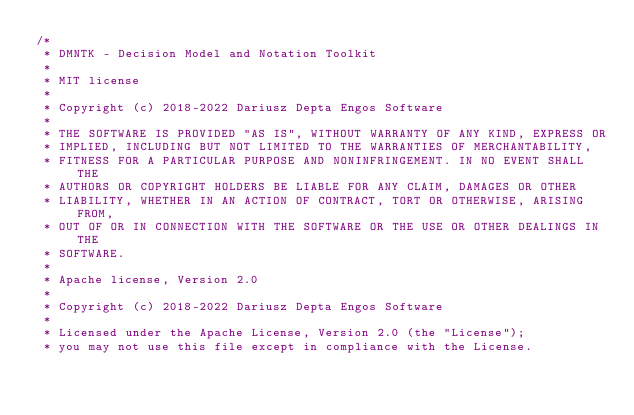<code> <loc_0><loc_0><loc_500><loc_500><_Rust_>/*
 * DMNTK - Decision Model and Notation Toolkit
 *
 * MIT license
 *
 * Copyright (c) 2018-2022 Dariusz Depta Engos Software
 *
 * THE SOFTWARE IS PROVIDED "AS IS", WITHOUT WARRANTY OF ANY KIND, EXPRESS OR
 * IMPLIED, INCLUDING BUT NOT LIMITED TO THE WARRANTIES OF MERCHANTABILITY,
 * FITNESS FOR A PARTICULAR PURPOSE AND NONINFRINGEMENT. IN NO EVENT SHALL THE
 * AUTHORS OR COPYRIGHT HOLDERS BE LIABLE FOR ANY CLAIM, DAMAGES OR OTHER
 * LIABILITY, WHETHER IN AN ACTION OF CONTRACT, TORT OR OTHERWISE, ARISING FROM,
 * OUT OF OR IN CONNECTION WITH THE SOFTWARE OR THE USE OR OTHER DEALINGS IN THE
 * SOFTWARE.
 *
 * Apache license, Version 2.0
 *
 * Copyright (c) 2018-2022 Dariusz Depta Engos Software
 *
 * Licensed under the Apache License, Version 2.0 (the "License");
 * you may not use this file except in compliance with the License.</code> 